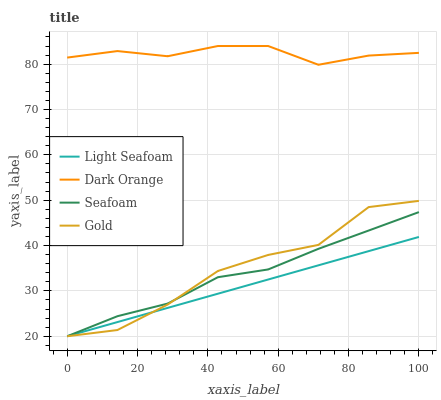Does Light Seafoam have the minimum area under the curve?
Answer yes or no. Yes. Does Dark Orange have the maximum area under the curve?
Answer yes or no. Yes. Does Seafoam have the minimum area under the curve?
Answer yes or no. No. Does Seafoam have the maximum area under the curve?
Answer yes or no. No. Is Light Seafoam the smoothest?
Answer yes or no. Yes. Is Gold the roughest?
Answer yes or no. Yes. Is Seafoam the smoothest?
Answer yes or no. No. Is Seafoam the roughest?
Answer yes or no. No. Does Light Seafoam have the lowest value?
Answer yes or no. Yes. Does Dark Orange have the highest value?
Answer yes or no. Yes. Does Seafoam have the highest value?
Answer yes or no. No. Is Gold less than Dark Orange?
Answer yes or no. Yes. Is Dark Orange greater than Light Seafoam?
Answer yes or no. Yes. Does Gold intersect Seafoam?
Answer yes or no. Yes. Is Gold less than Seafoam?
Answer yes or no. No. Is Gold greater than Seafoam?
Answer yes or no. No. Does Gold intersect Dark Orange?
Answer yes or no. No. 